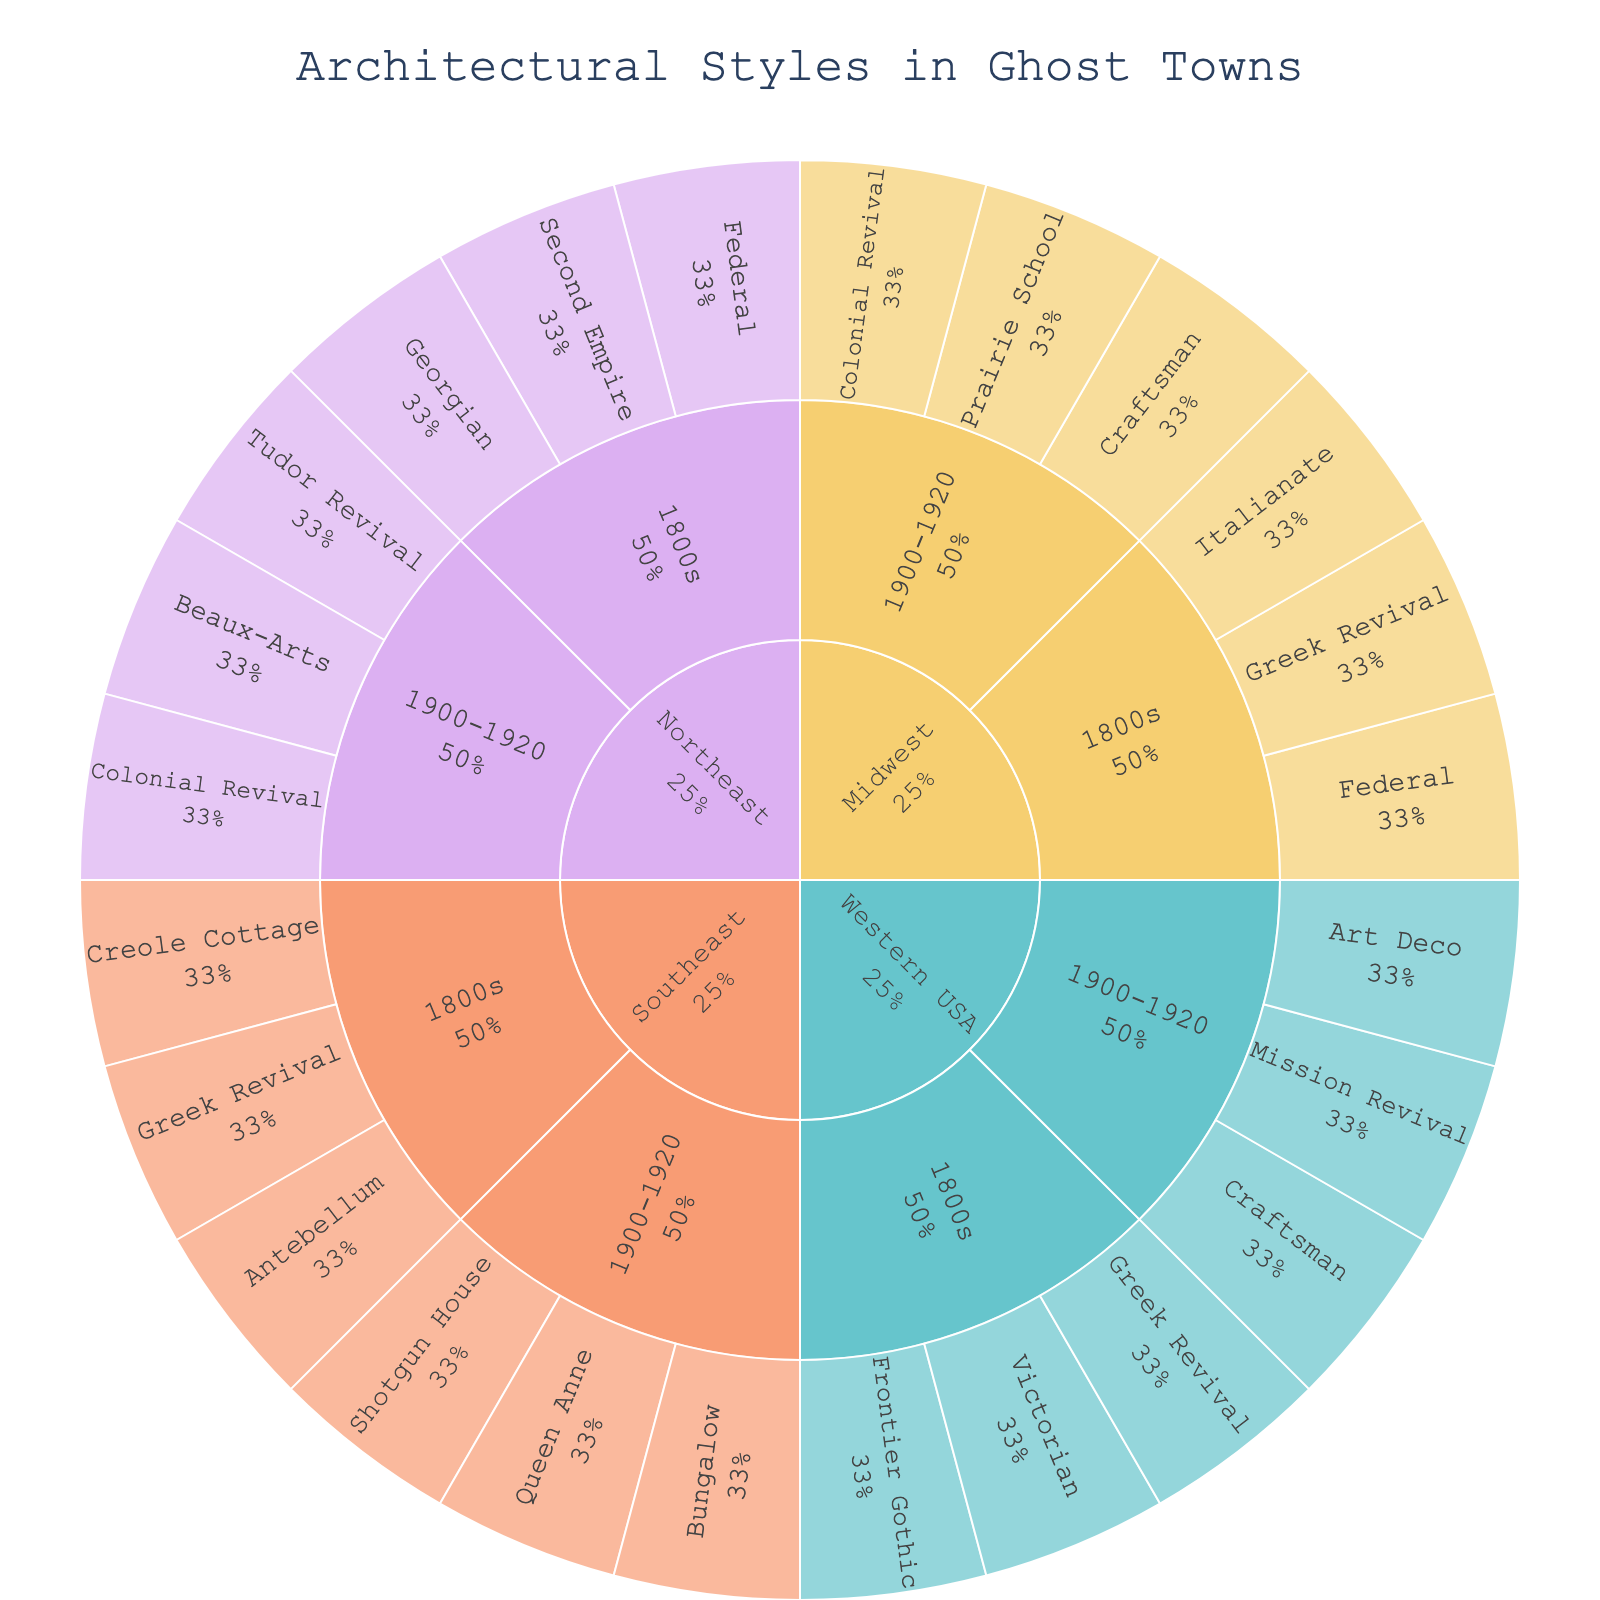what regions are included in the plot? Look at the outermost layer of the sunburst plot, which lists the main categories for regions: Western USA, Midwest, Southeast, and Northeast.
Answer: Western USA, Midwest, Southeast, Northeast What architectural styles are found in the Midwest during the 1800s? Find the Midwest region in the sunburst plot and then locate the subcategory for the 1800s. The styles listed under this subcategory are: Federal, Greek Revival, and Italianate.
Answer: Federal, Greek Revival, Italianate Which period demonstrates the most diversity in architectural styles in the Western USA? Look at the sections for the Western USA; compare the number of sub-styles listed under the 1800s and 1900-1920. The 1800s have three styles (Victorian, Frontier Gothic, Greek Revival), whereas 1900-1920 has three styles (Craftsman, Art Deco, Mission Revival). Both periods show the same diversity.
Answer: Both periods have three styles Are there any shared architectural styles between the Southeast and Northeast regions during the 1900-1920 period? Identify the architectural styles listed in the Southeast (Bungalow, Shotgun House, Queen Anne) and Northeast (Beaux-Arts, Tudor Revival, Colonial Revival) under the 1900-1920 period. Look for any common styles. The shared style is Colonial Revival.
Answer: Colonial Revival Which region has the most architectural styles listed in the 1800s? Count the number of architectural styles in each region's 1800s section. Western USA (3 styles), Midwest (3 styles), Southeast (3 styles), and Northeast (3 styles). All regions have the same number of styles in the 1800s.
Answer: All regions have 3 styles What percentage of the Western USA's architectural styles are from the 1800s? In the sunburst plot, the Western USA has a total of 6 architectural styles. Of these, 3 are from the 1800s. Dividing 3 by 6 and multiplying by 100 gives 50%.
Answer: 50% Which period in the Northeast presents the highest presence of unique architectural styles not found in other regions? Compare the architectural styles listed in the Northeast during the 1800s and 1900-1920 against those of other regions. The 1800s styles are Federal, Georgian, and Second Empire. The 1900-1920 styles include Beaux-Arts, Tudor Revival, and Colonial Revival. The unique styles are Georgian and Second Empire from the 1800s, and Beaux-Arts and Tudor Revival from 1900-1920. The Northeast has more unique styles in the 1900-1920 period.
Answer: 1900-1920, with Beaux-Arts and Tudor Revival Which architectural style is found in multiple regions during the 1800s? Compare architectural styles from the 1800s across all regions. The shared style is Greek Revival, found in the Western USA, Midwest, and Southeast.
Answer: Greek Revival 